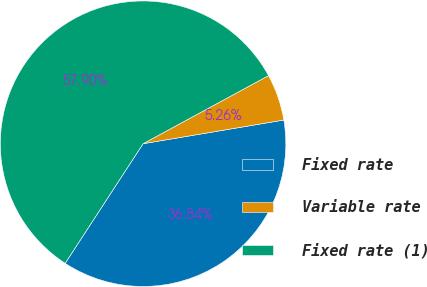Convert chart to OTSL. <chart><loc_0><loc_0><loc_500><loc_500><pie_chart><fcel>Fixed rate<fcel>Variable rate<fcel>Fixed rate (1)<nl><fcel>36.84%<fcel>5.26%<fcel>57.89%<nl></chart> 